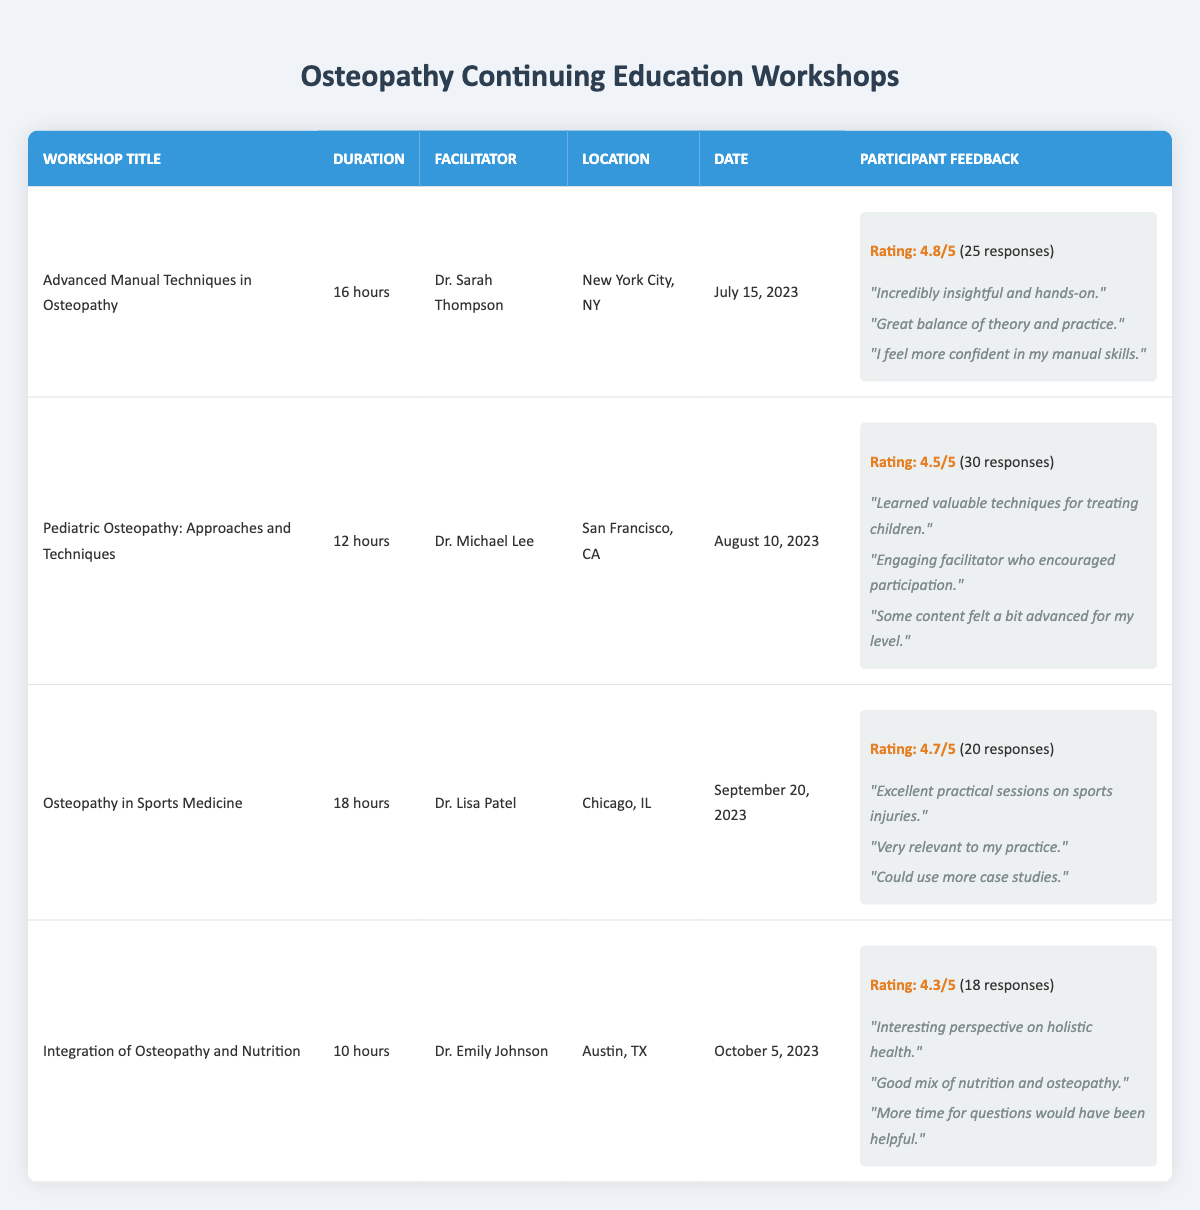What is the duration of the workshop "Integration of Osteopathy and Nutrition"? The table indicates that the duration of the workshop "Integration of Osteopathy and Nutrition" is specified as 10 hours in the second column.
Answer: 10 hours Who was the facilitator for the "Advanced Manual Techniques in Osteopathy" workshop? By looking at the respective row in the table, the facilitator for the "Advanced Manual Techniques in Osteopathy" workshop is Dr. Sarah Thompson, listed in the third column.
Answer: Dr. Sarah Thompson How many total feedback responses were collected for the "Osteopathy in Sports Medicine" workshop? The total feedback responses for the "Osteopathy in Sports Medicine" workshop are provided in the last column, which states 20 responses.
Answer: 20 What is the average rating of the "Pediatric Osteopathy: Approaches and Techniques" workshop? According to the table, the average rating for the "Pediatric Osteopathy: Approaches and Techniques" workshop is indicated as 4.5 in the last column under participant feedback.
Answer: 4.5 Which workshop received the highest average rating? We need to compare the average ratings across multiple workshops listed in the table: 4.8 for "Advanced Manual Techniques in Osteopathy", 4.5 for "Pediatric Osteopathy", 4.7 for "Osteopathy in Sports Medicine", and 4.3 for "Integration of Osteopathy and Nutrition". Upon comparison, "Advanced Manual Techniques in Osteopathy" has the highest rating of 4.8.
Answer: Advanced Manual Techniques in Osteopathy Did the "Integration of Osteopathy and Nutrition" workshop have more than 15 feedback responses? Reviewing the total feedback responses for the "Integration of Osteopathy and Nutrition" workshop, which is 18 responses, we can confirm that it exceeds 15 responses.
Answer: Yes What is the total duration of all workshops combined? By summing the durations: 16 hours (Advanced Manual Techniques) + 12 hours (Pediatric Osteopathy) + 18 hours (Osteopathy in Sports Medicine) + 10 hours (Integration of Osteopathy and Nutrition) gives us a total of 56 hours of workshops combined.
Answer: 56 hours How many comments did participants provide for the "Osteopathy in Sports Medicine"? In reviewing the participant feedback for "Osteopathy in Sports Medicine," the workshop received three comments, which can be counted from the feedback section.
Answer: 3 comments Which workshop took place in September 2023? From the table, we can see that the "Osteopathy in Sports Medicine" workshop is listed with a date of September 20, 2023.
Answer: Osteopathy in Sports Medicine 